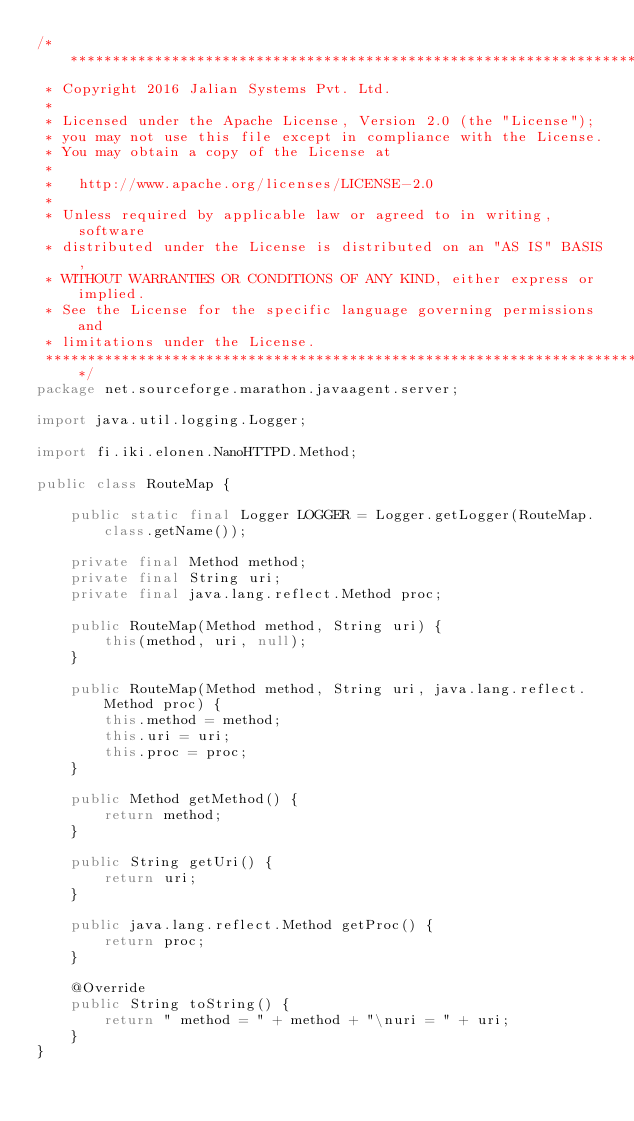<code> <loc_0><loc_0><loc_500><loc_500><_Java_>/*******************************************************************************
 * Copyright 2016 Jalian Systems Pvt. Ltd.
 * 
 * Licensed under the Apache License, Version 2.0 (the "License");
 * you may not use this file except in compliance with the License.
 * You may obtain a copy of the License at
 * 
 *   http://www.apache.org/licenses/LICENSE-2.0
 * 
 * Unless required by applicable law or agreed to in writing, software
 * distributed under the License is distributed on an "AS IS" BASIS,
 * WITHOUT WARRANTIES OR CONDITIONS OF ANY KIND, either express or implied.
 * See the License for the specific language governing permissions and
 * limitations under the License.
 ******************************************************************************/
package net.sourceforge.marathon.javaagent.server;

import java.util.logging.Logger;

import fi.iki.elonen.NanoHTTPD.Method;

public class RouteMap {

    public static final Logger LOGGER = Logger.getLogger(RouteMap.class.getName());

    private final Method method;
    private final String uri;
    private final java.lang.reflect.Method proc;

    public RouteMap(Method method, String uri) {
        this(method, uri, null);
    }

    public RouteMap(Method method, String uri, java.lang.reflect.Method proc) {
        this.method = method;
        this.uri = uri;
        this.proc = proc;
    }

    public Method getMethod() {
        return method;
    }

    public String getUri() {
        return uri;
    }

    public java.lang.reflect.Method getProc() {
        return proc;
    }

    @Override
    public String toString() {
        return " method = " + method + "\nuri = " + uri;
    }
}
</code> 